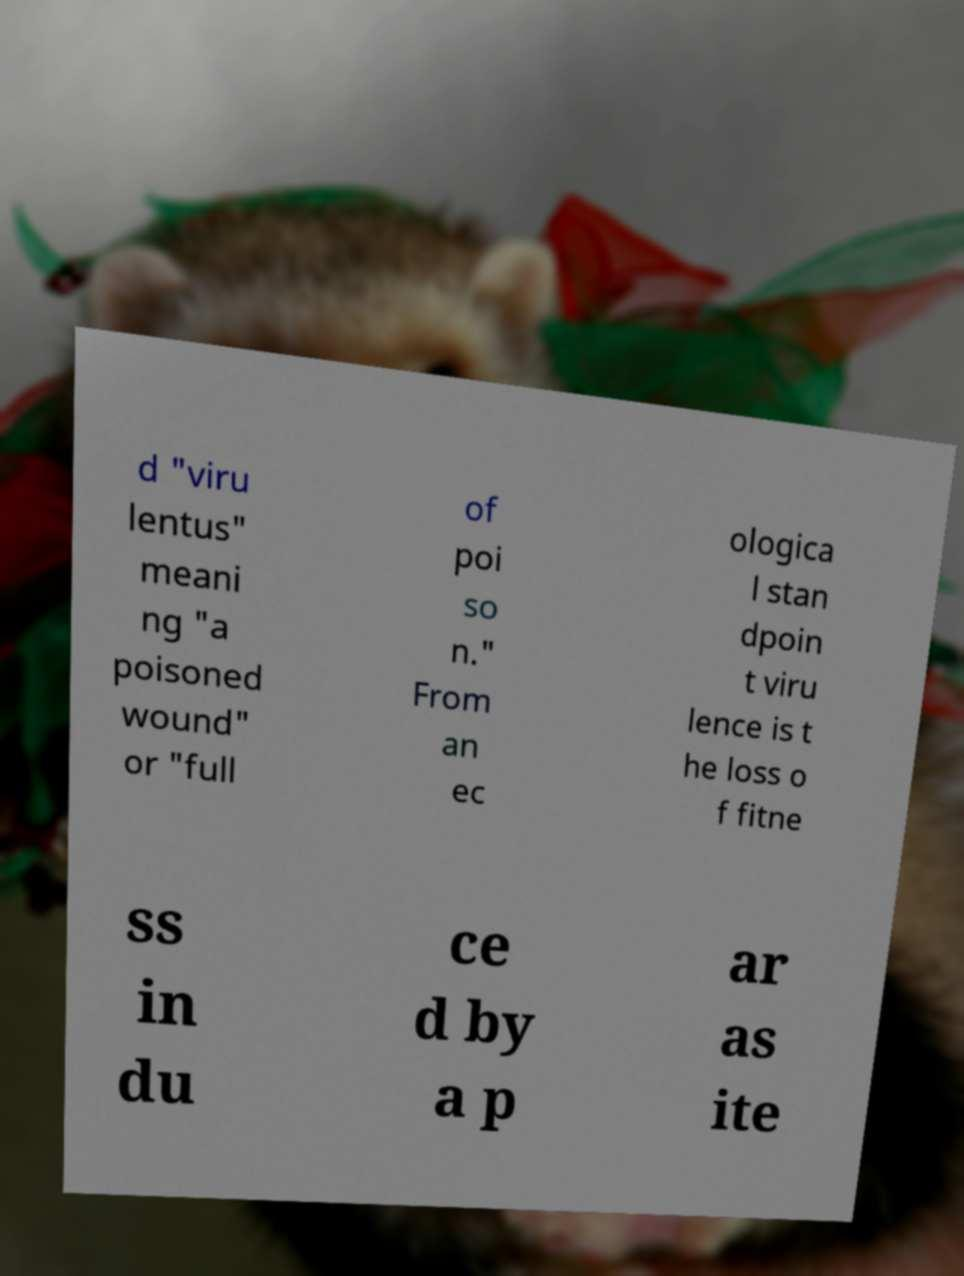I need the written content from this picture converted into text. Can you do that? d "viru lentus" meani ng "a poisoned wound" or "full of poi so n." From an ec ologica l stan dpoin t viru lence is t he loss o f fitne ss in du ce d by a p ar as ite 